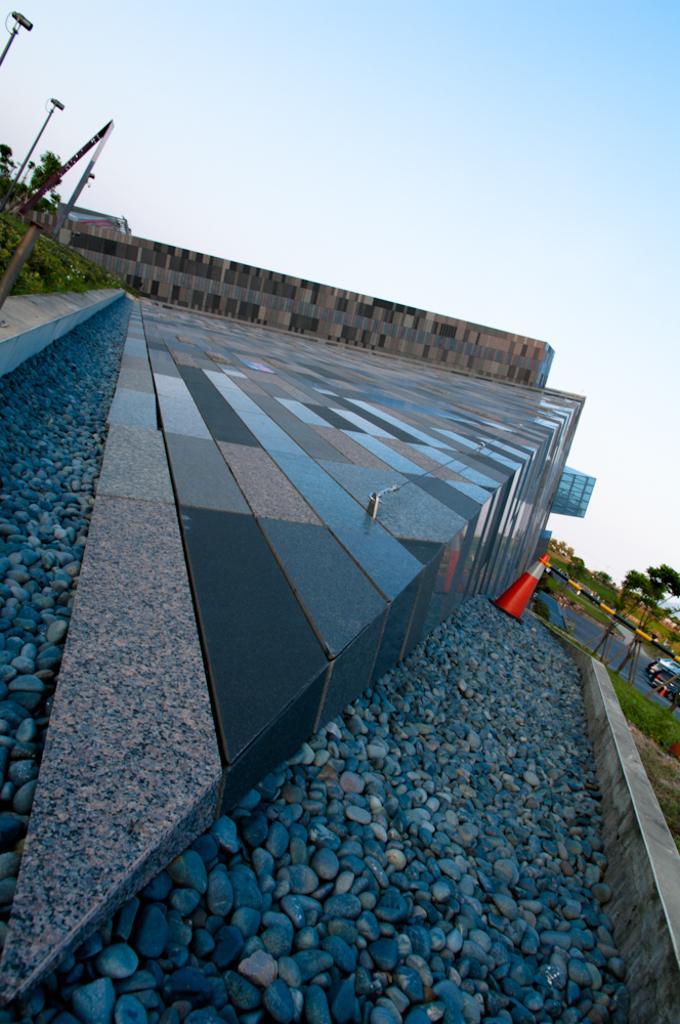In one or two sentences, can you explain what this image depicts? In this picture we can see a building, stones, traffic cone, poles, grass, trees, and a vehicle. In the background there is sky. 